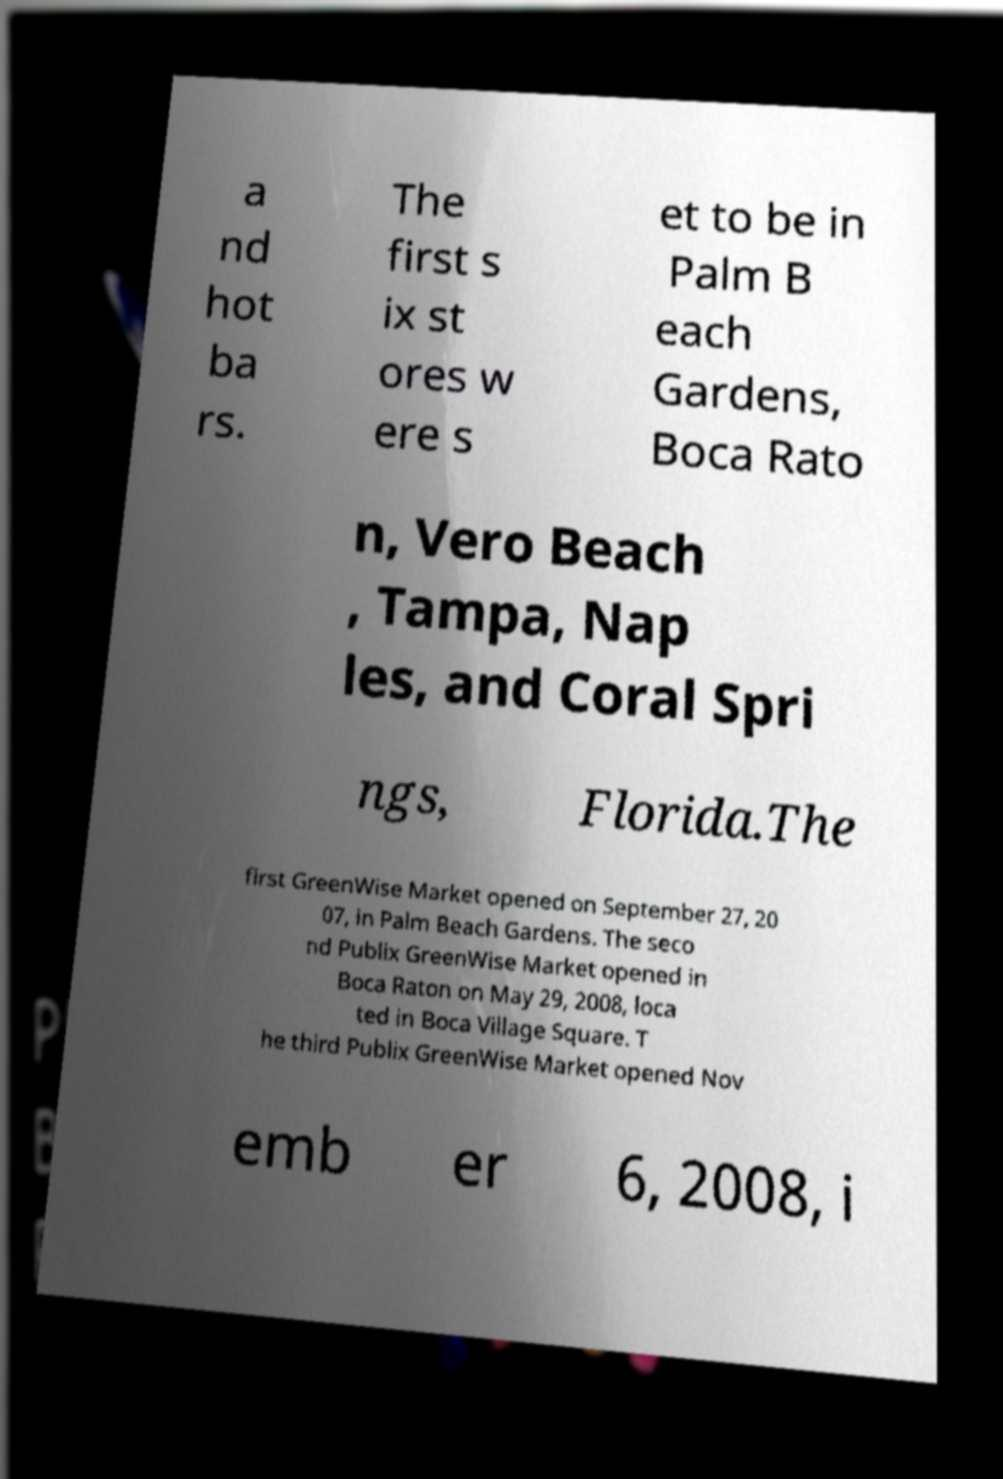There's text embedded in this image that I need extracted. Can you transcribe it verbatim? a nd hot ba rs. The first s ix st ores w ere s et to be in Palm B each Gardens, Boca Rato n, Vero Beach , Tampa, Nap les, and Coral Spri ngs, Florida.The first GreenWise Market opened on September 27, 20 07, in Palm Beach Gardens. The seco nd Publix GreenWise Market opened in Boca Raton on May 29, 2008, loca ted in Boca Village Square. T he third Publix GreenWise Market opened Nov emb er 6, 2008, i 